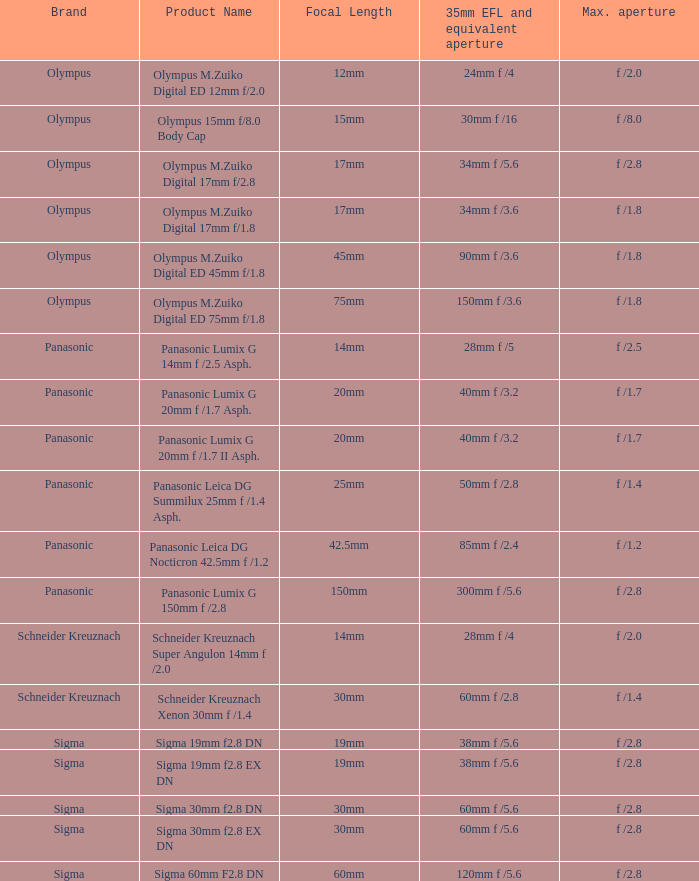8 dn, with a top aperture of f / Sigma. 